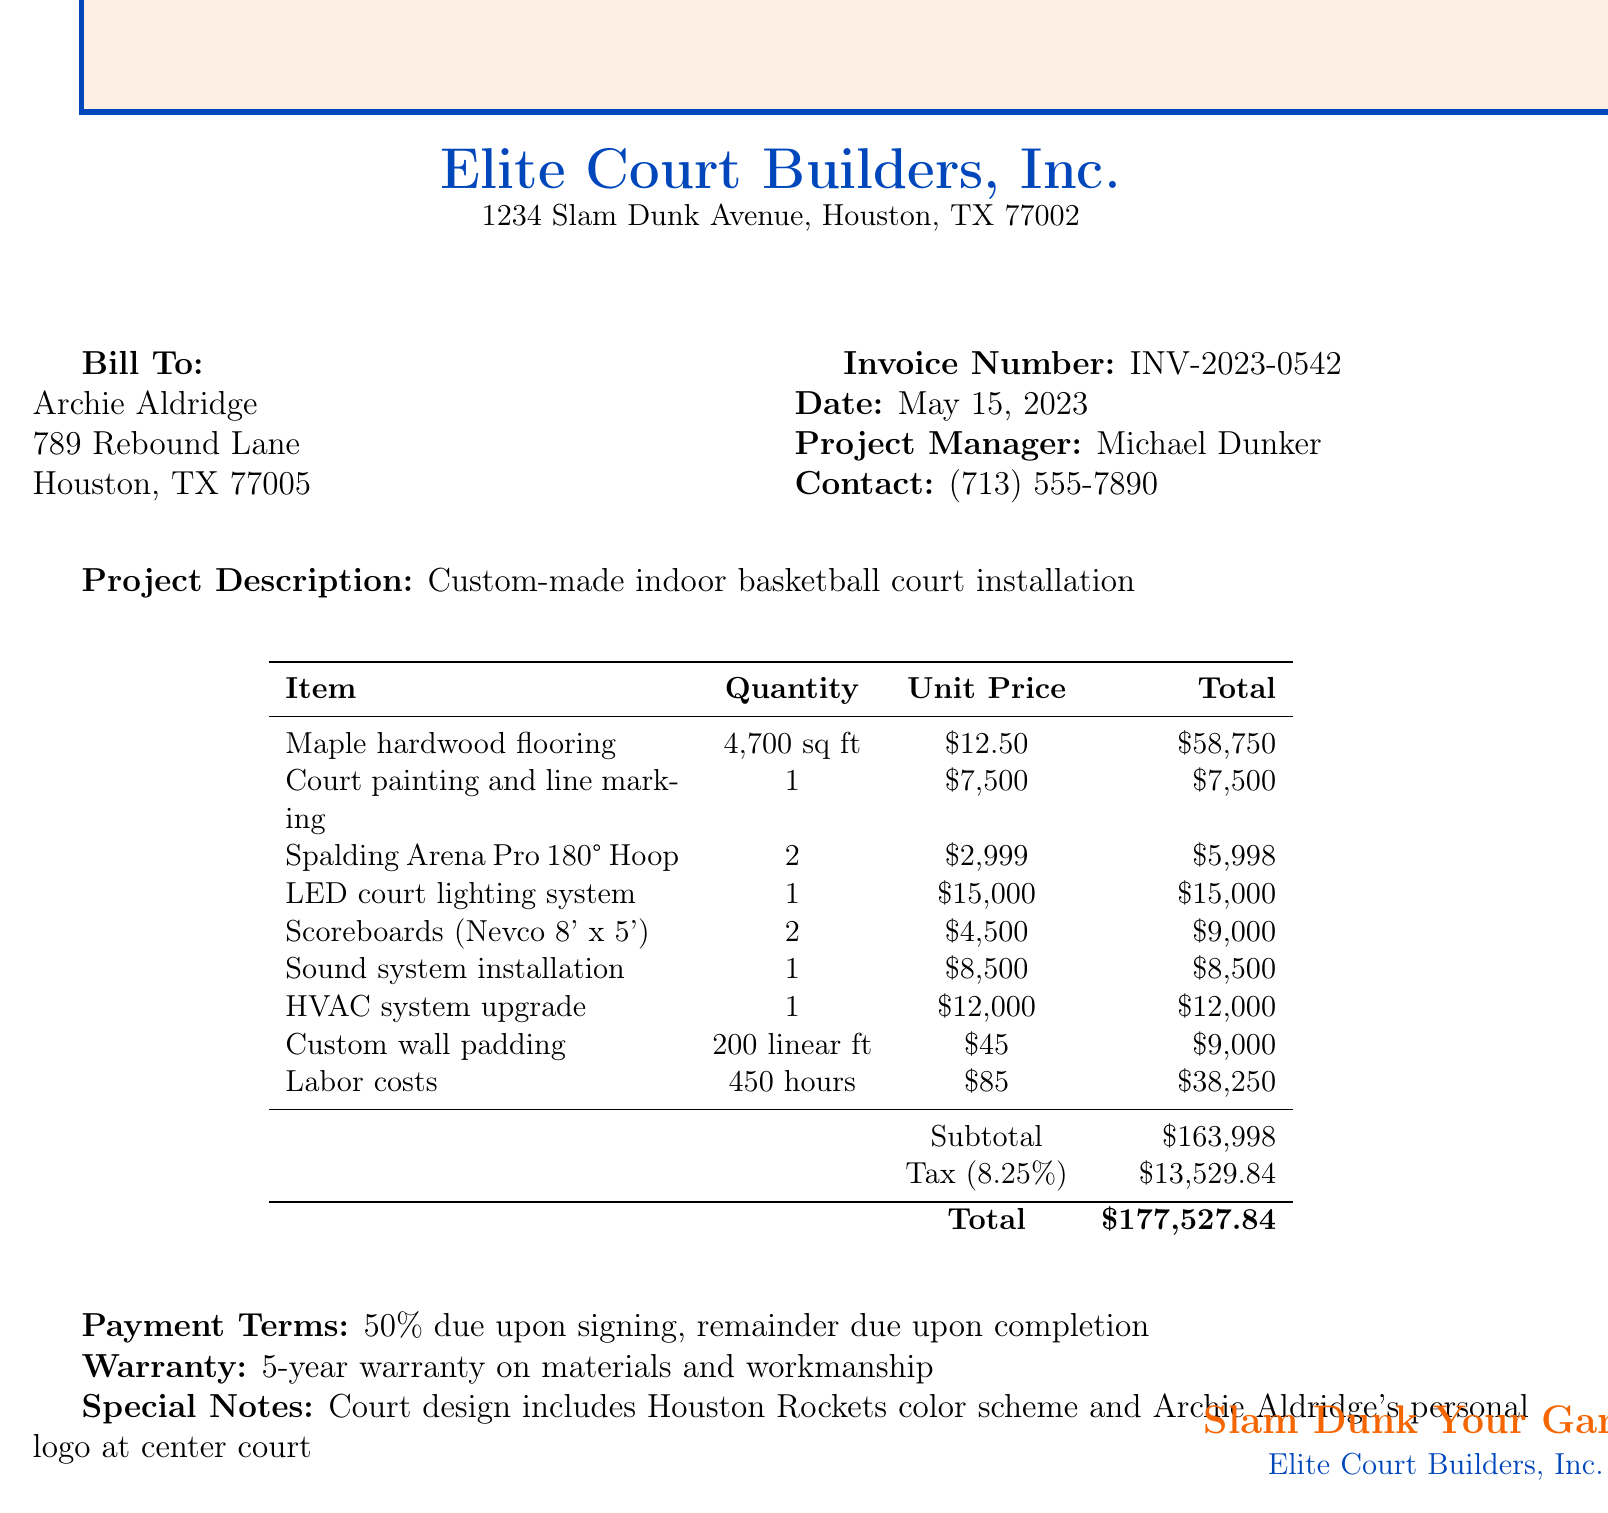What is the invoice number? The invoice number can be found in the document, listed under "Invoice Number."
Answer: INV-2023-0542 Who is the project manager? The name of the project manager is provided in the document under the contact information section.
Answer: Michael Dunker What is the total amount due? The total amount due is listed in the document, representing the final cost including all charges and taxes.
Answer: $177,527.84 How many square feet of flooring were installed? The document specifies the quantity of maple hardwood flooring installed under itemized costs.
Answer: 4,700 sq ft What is the tax rate applied? The tax rate can be found in the document next to the tax amount.
Answer: 8.25% What warranty is provided for the installation? The warranty information is mentioned towards the end of the document.
Answer: 5-year warranty on materials and workmanship How much was charged for labor costs? The labor costs are detailed in the itemized costs section of the document.
Answer: $38,250 What special design feature is included in the court? The document includes a note regarding a specific feature of the court’s design.
Answer: Houston Rockets color scheme and Archie Aldridge's personal logo at center court How much is due upon signing? The payment terms detail the amount required to be paid when signing.
Answer: 50% 